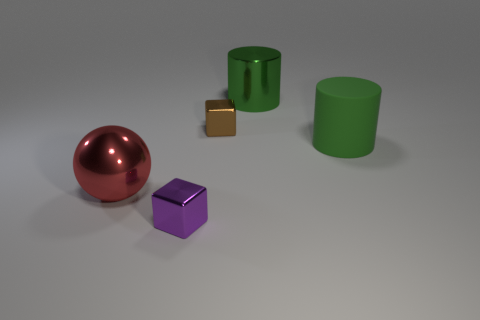What number of objects are big brown cylinders or large green things?
Your answer should be compact. 2. There is another small thing that is made of the same material as the purple object; what shape is it?
Your response must be concise. Cube. What size is the green object in front of the small metallic thing that is behind the red shiny ball?
Give a very brief answer. Large. How many large things are either blue shiny spheres or green shiny objects?
Provide a short and direct response. 1. What number of other objects are there of the same color as the big rubber cylinder?
Keep it short and to the point. 1. Is the size of the block that is in front of the big shiny sphere the same as the block behind the purple metal thing?
Ensure brevity in your answer.  Yes. Does the small brown thing have the same material as the large thing left of the tiny purple shiny thing?
Give a very brief answer. Yes. Are there more big rubber things in front of the large red metal thing than tiny purple cubes that are behind the purple thing?
Make the answer very short. No. What color is the cylinder behind the tiny metallic block on the right side of the purple metallic block?
Provide a succinct answer. Green. How many balls are big green objects or large metallic objects?
Keep it short and to the point. 1. 